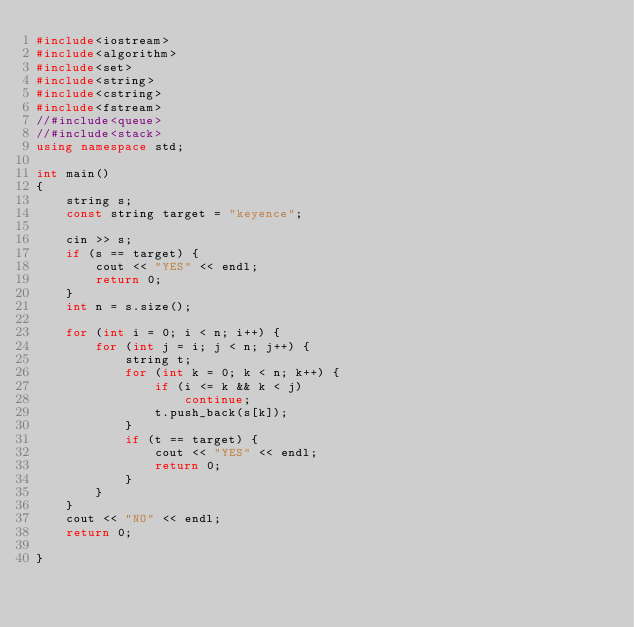Convert code to text. <code><loc_0><loc_0><loc_500><loc_500><_C++_>#include<iostream>
#include<algorithm>
#include<set>
#include<string>
#include<cstring>
#include<fstream>
//#include<queue>
//#include<stack>
using namespace std;

int main()
{
	string s;
	const string target = "keyence";

	cin >> s;
	if (s == target) {
		cout << "YES" << endl;
		return 0;
	}
	int n = s.size();

	for (int i = 0; i < n; i++) {
		for (int j = i; j < n; j++) {
			string t;
			for (int k = 0; k < n; k++) {
				if (i <= k && k < j)
					continue;
				t.push_back(s[k]);
			}
			if (t == target) {
				cout << "YES" << endl;
				return 0;
			}
		}
	}
	cout << "NO" << endl;
	return 0;

}</code> 